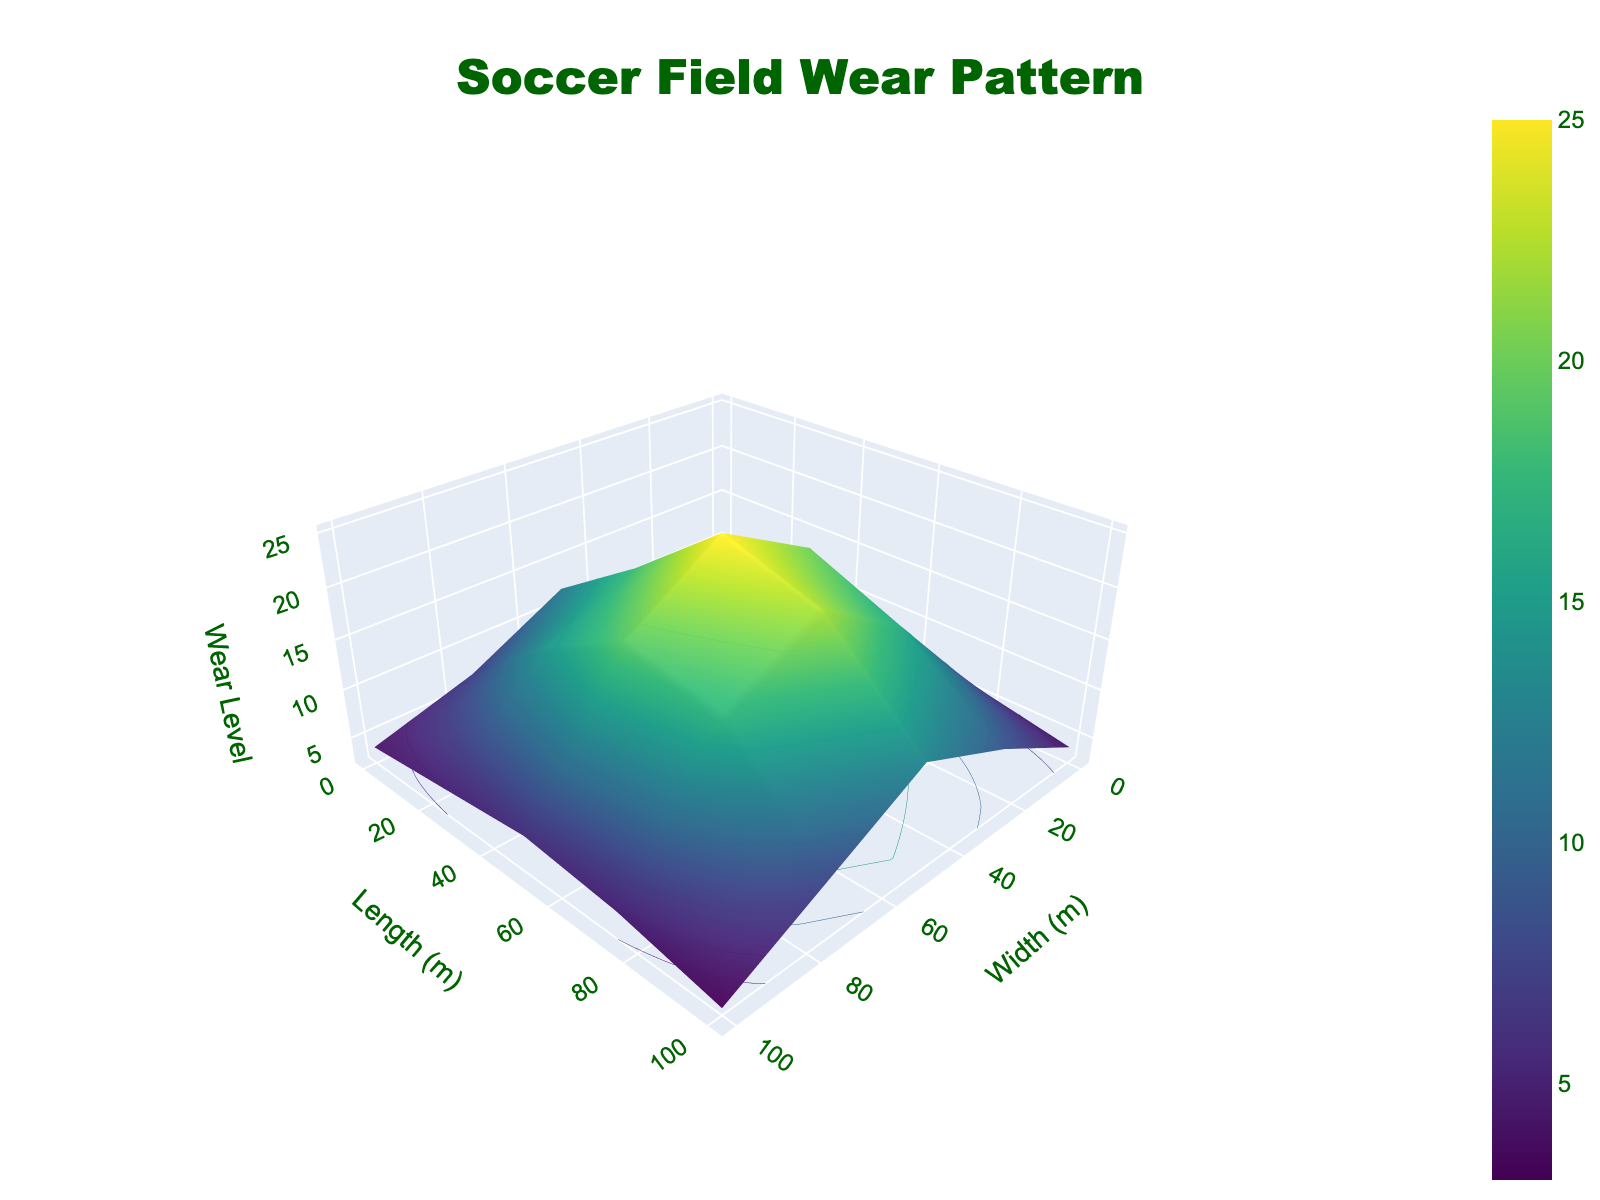What's the title of the plot? The title is typically displayed at the top of the plot. In this case, it says "Soccer Field Wear Pattern."
Answer: Soccer Field Wear Pattern What is the wear level near the center of the field? The center of the field corresponds to the middle coordinates, which are (50, 50). Looking at the plot, the wear level at (50, 50) is the highest value, which is 25.
Answer: 25 Where is the lowest wear level on the field? To find the lowest wear level, examine the plot for the smallest z-value. The smallest wear level appears to be at the corners of the field such as (100, 100), with a wear level of 3.
Answer: (100, 100) What’s the difference in wear level between the corners (0, 0) and (100, 100)? From the plot, the wear level at (0, 0) is 5 and at (100, 100) is 3. The difference is calculated as 5 - 3 = 2.
Answer: 2 Which side of the field shows the highest wear level, the left (x=0) or the right (x=100)? By examining the plot, especially the ends where x=0 and x=100, the highest wear level on the y-axis for x=0 is 12, while for x=100, it is 13. Therefore, the right side (x=100) shows higher wear levels.
Answer: right How many peaks of wear level greater than 20 are there on the field? Looking closely at the surface plot, there are contours that indicate where wear levels exceed 20. From the plot, these appear in two locations: (50, 25) and (75, 50).
Answer: 2 What is the average wear level at the four corners of the field? The wear levels at the four corners are (0, 0) = 5, (0, 100) = 4, (100, 0) = 4, and (100, 100) = 3. The average is (5 + 4 + 4 + 3) / 4 = 16 / 4 = 4.
Answer: 4 What’s the wear difference between the top side (y=0) and bottom side (y=100)? On the y=0 side, the wear levels are 5, 6, 7, 6, and 4. Their average is (5 + 6 + 7 + 6 + 4) / 5 = 28 / 5 = 5.6. On the y=100 side, the wear levels are 4, 5, 6, 5, and 3. Their average is (4 + 5 + 6 + 5 + 3) / 5 = 23 / 5 = 4.6. The difference is 5.6 - 4.6 = 1.0.
Answer: 1.0 Is the wear level generally higher in the middle of the field compared to the edges? Observing the plot, the central region (e.g., around (50, 50) and (75, 50)) shows wear levels up to 25, while the edges notably have lower wear levels, typically between 3 and 9. This suggests higher wear in the middle.
Answer: yes 